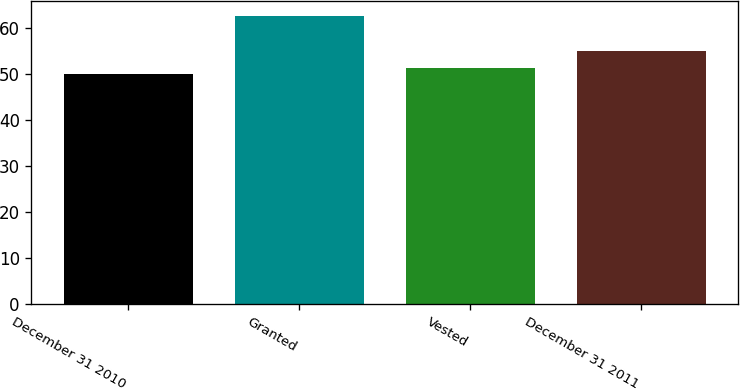Convert chart to OTSL. <chart><loc_0><loc_0><loc_500><loc_500><bar_chart><fcel>December 31 2010<fcel>Granted<fcel>Vested<fcel>December 31 2011<nl><fcel>49.95<fcel>62.68<fcel>51.27<fcel>54.87<nl></chart> 